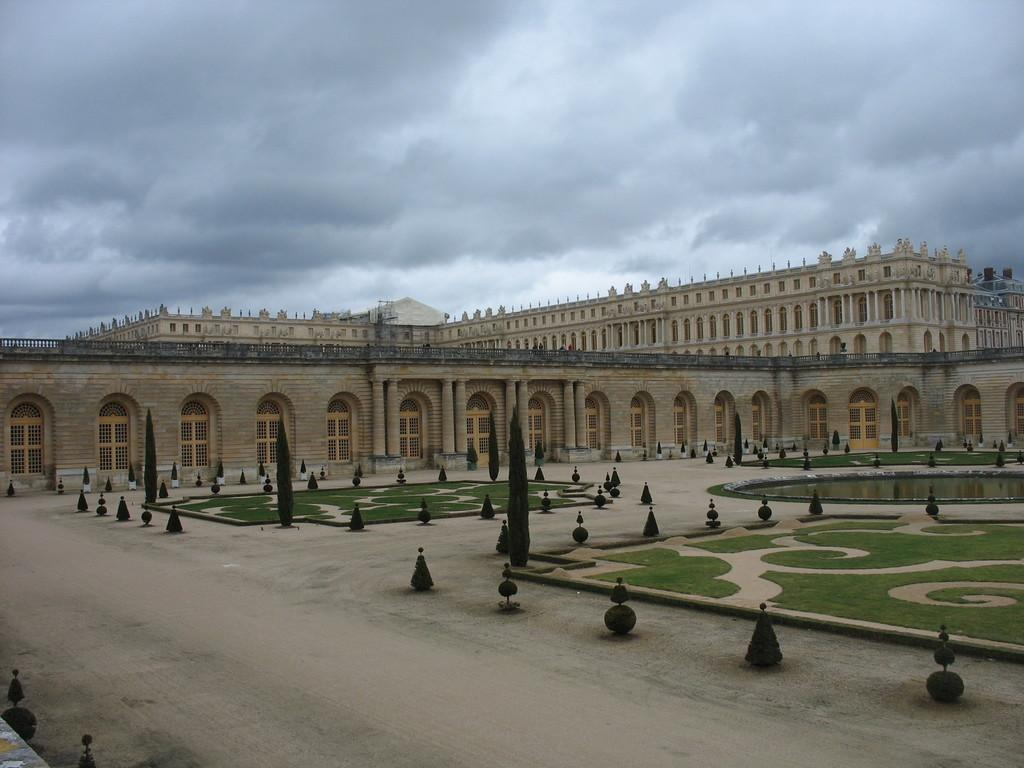What type of building is shown in the image? The image appears to depict a palace. What can be seen in the foreground of the image? There are plants arranged in a circular shape in the foreground. What is visible at the top of the image? The sky is visible at the top of the image. What can be observed in the sky? Clouds are present in the sky. Where is the nearest store to the palace in the image? There is no information about a store or its location in the image. What type of prose can be heard coming from the palace in the image? There is no indication of any prose or sounds in the image, as it is a static representation of a palace and its surroundings. 